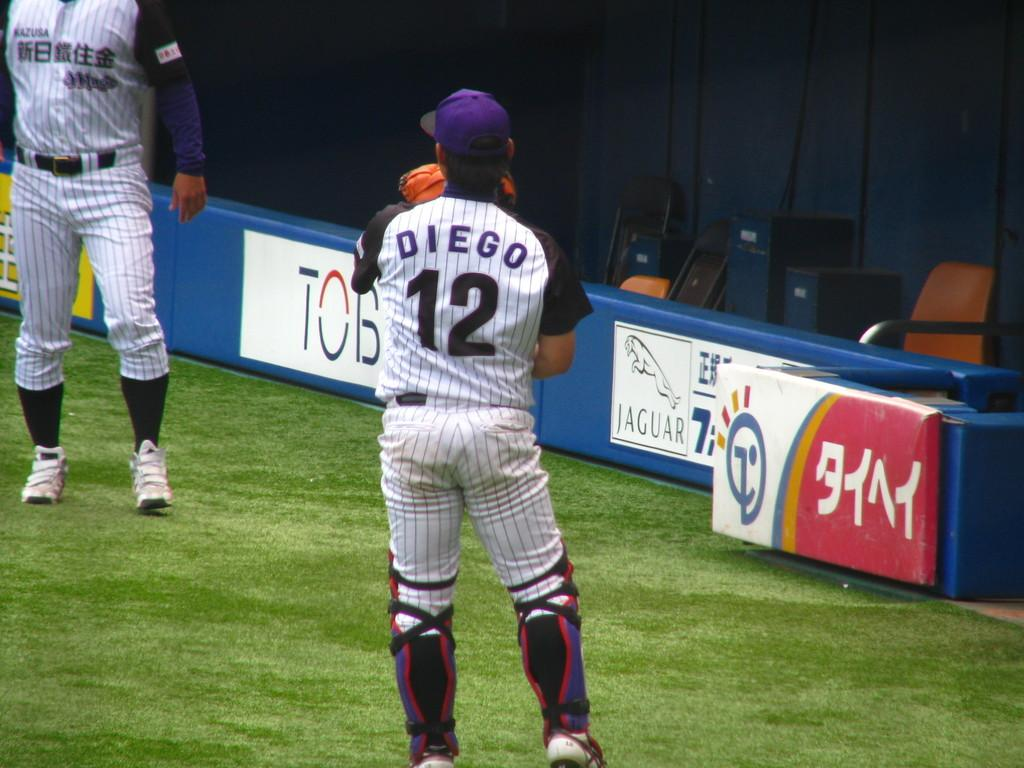<image>
Share a concise interpretation of the image provided. A man with Diego 12 on his shirt playing catch. 